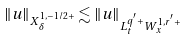Convert formula to latex. <formula><loc_0><loc_0><loc_500><loc_500>\| u \| _ { X _ { \delta } ^ { 1 , - 1 / 2 + } } \lesssim \| u \| _ { L _ { t } ^ { q ^ { ^ { \prime } } + } W _ { x } ^ { 1 , r ^ { ^ { \prime } } + } }</formula> 